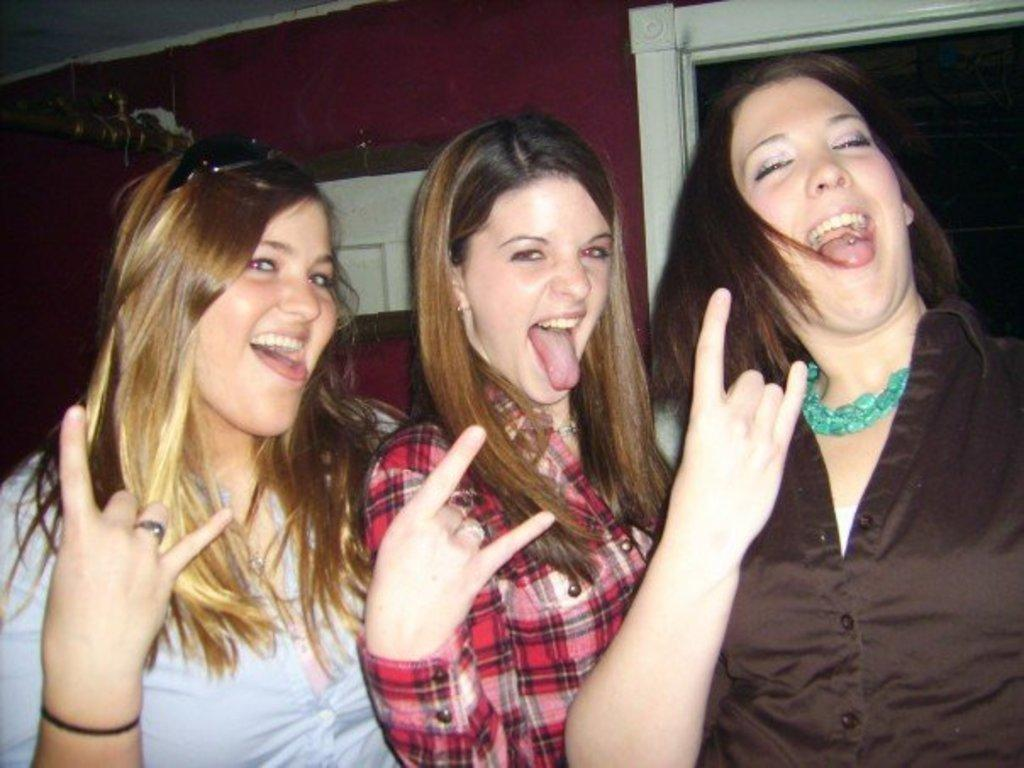How many people are in the image? There are three women in the image. What are the women doing in the image? The women are standing. What can be seen in the background of the image? There is a wall in the background of the image. What type of apple can be seen hanging from the wall in the image? There is no apple present in the image, and therefore no such object can be observed hanging from the wall. 